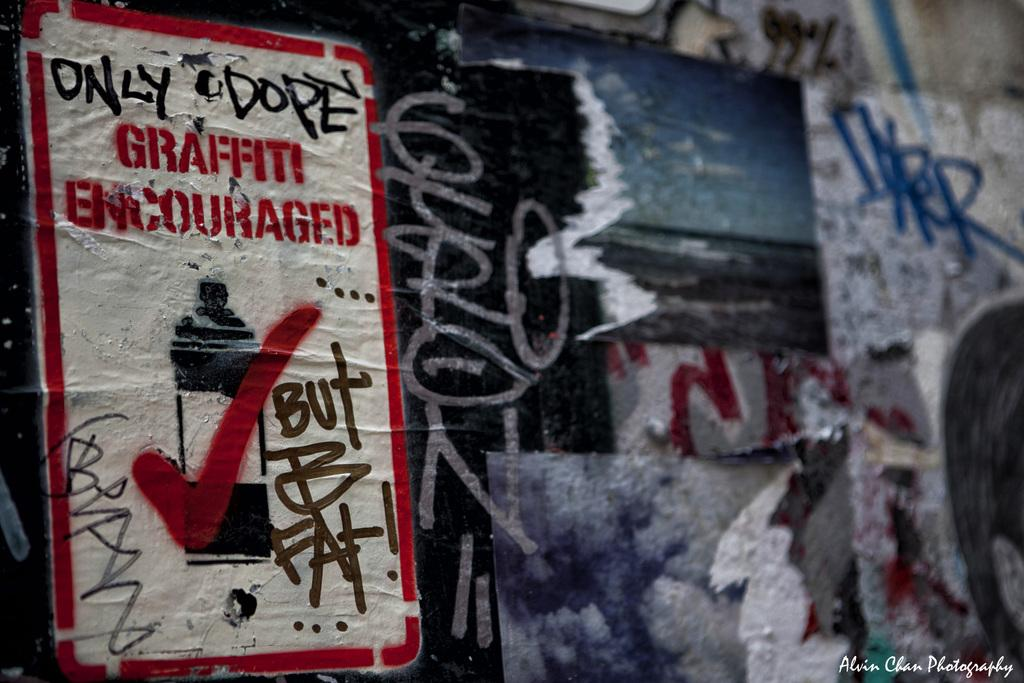<image>
Describe the image concisely. A wall with an extreme amount of graffiti on it and a sign saying graffiti is encouraged. 